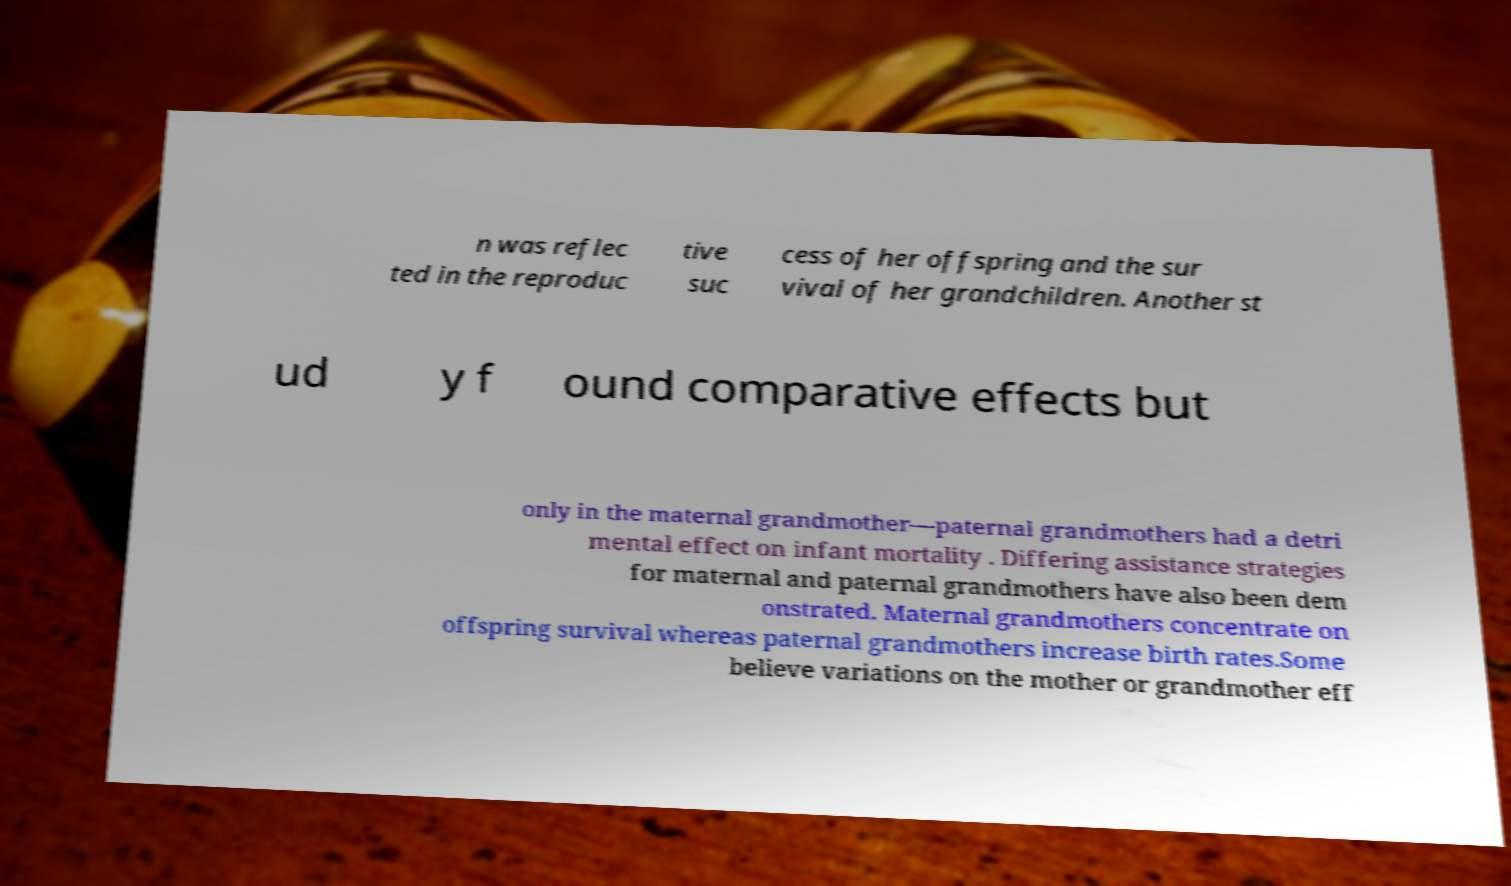What messages or text are displayed in this image? I need them in a readable, typed format. n was reflec ted in the reproduc tive suc cess of her offspring and the sur vival of her grandchildren. Another st ud y f ound comparative effects but only in the maternal grandmother—paternal grandmothers had a detri mental effect on infant mortality . Differing assistance strategies for maternal and paternal grandmothers have also been dem onstrated. Maternal grandmothers concentrate on offspring survival whereas paternal grandmothers increase birth rates.Some believe variations on the mother or grandmother eff 